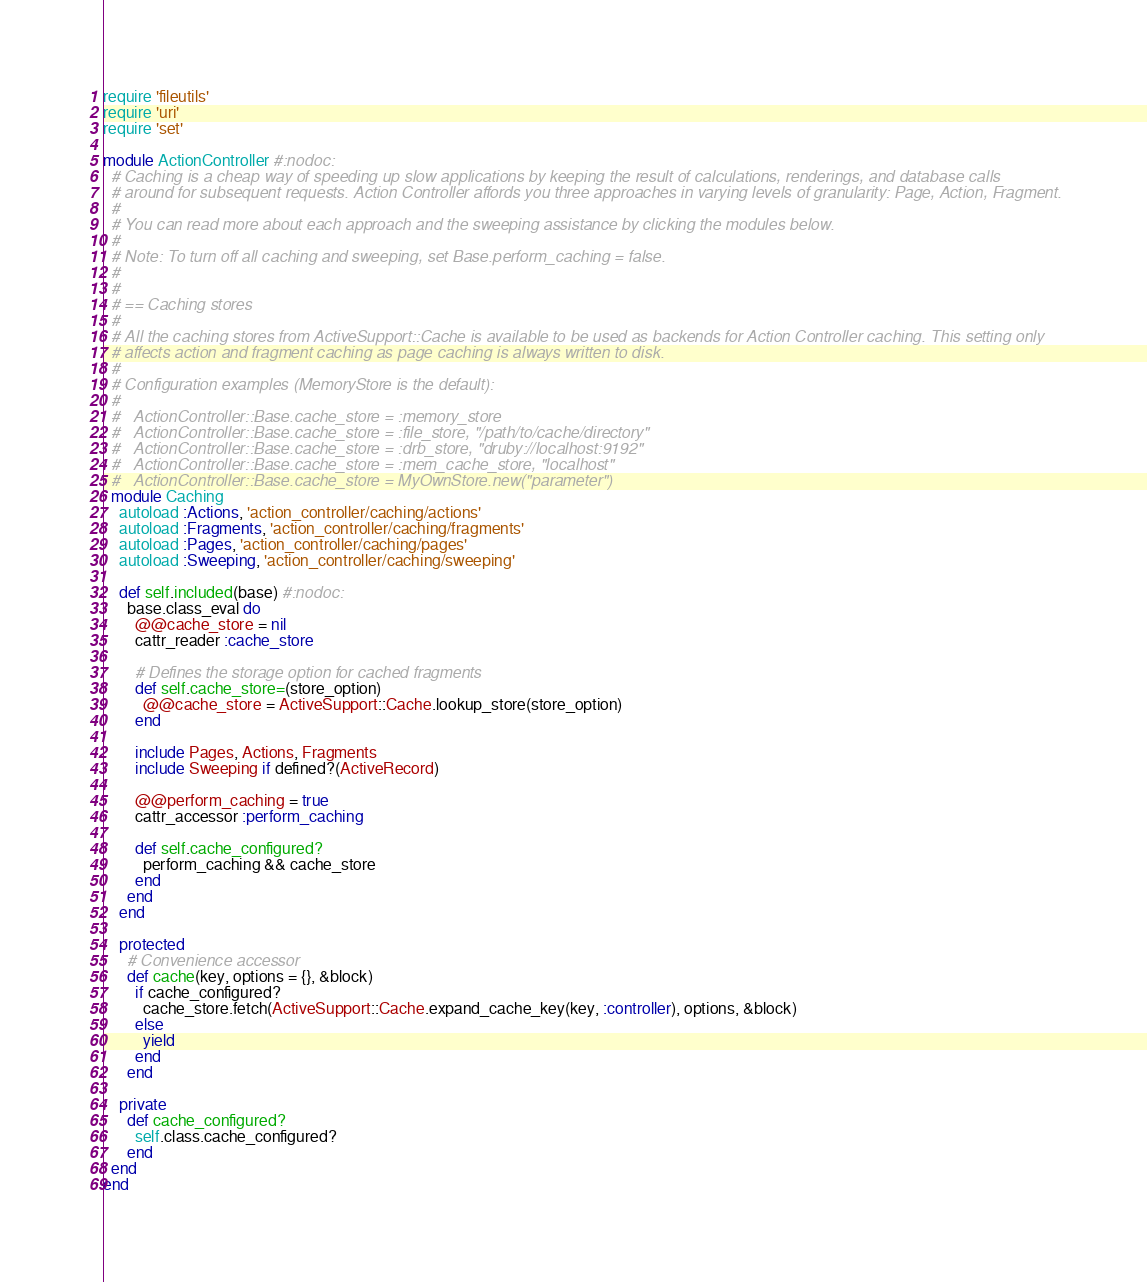<code> <loc_0><loc_0><loc_500><loc_500><_Ruby_>require 'fileutils'
require 'uri'
require 'set'

module ActionController #:nodoc:
  # Caching is a cheap way of speeding up slow applications by keeping the result of calculations, renderings, and database calls
  # around for subsequent requests. Action Controller affords you three approaches in varying levels of granularity: Page, Action, Fragment.
  #
  # You can read more about each approach and the sweeping assistance by clicking the modules below.
  #
  # Note: To turn off all caching and sweeping, set Base.perform_caching = false.
  #
  #
  # == Caching stores
  #
  # All the caching stores from ActiveSupport::Cache is available to be used as backends for Action Controller caching. This setting only
  # affects action and fragment caching as page caching is always written to disk.
  #
  # Configuration examples (MemoryStore is the default):
  #
  #   ActionController::Base.cache_store = :memory_store
  #   ActionController::Base.cache_store = :file_store, "/path/to/cache/directory"
  #   ActionController::Base.cache_store = :drb_store, "druby://localhost:9192"
  #   ActionController::Base.cache_store = :mem_cache_store, "localhost"
  #   ActionController::Base.cache_store = MyOwnStore.new("parameter")
  module Caching
    autoload :Actions, 'action_controller/caching/actions'
    autoload :Fragments, 'action_controller/caching/fragments'
    autoload :Pages, 'action_controller/caching/pages'
    autoload :Sweeping, 'action_controller/caching/sweeping'

    def self.included(base) #:nodoc:
      base.class_eval do
        @@cache_store = nil
        cattr_reader :cache_store

        # Defines the storage option for cached fragments
        def self.cache_store=(store_option)
          @@cache_store = ActiveSupport::Cache.lookup_store(store_option)
        end

        include Pages, Actions, Fragments
        include Sweeping if defined?(ActiveRecord)

        @@perform_caching = true
        cattr_accessor :perform_caching

        def self.cache_configured?
          perform_caching && cache_store
        end
      end
    end

    protected
      # Convenience accessor
      def cache(key, options = {}, &block)
        if cache_configured?
          cache_store.fetch(ActiveSupport::Cache.expand_cache_key(key, :controller), options, &block)
        else
          yield
        end
      end

    private
      def cache_configured?
        self.class.cache_configured?
      end
  end
end
</code> 